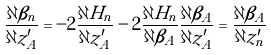<formula> <loc_0><loc_0><loc_500><loc_500>\frac { \partial \beta _ { n } } { \partial z ^ { \prime } _ { A } } = - 2 \frac { \partial H _ { n } } { \partial z ^ { \prime } _ { A } } - 2 \frac { \partial H _ { n } } { \partial \beta _ { A } } \frac { \partial \beta _ { A } } { \partial z ^ { \prime } _ { A } } = \frac { \partial \beta _ { A } } { \partial z ^ { \prime } _ { n } }</formula> 